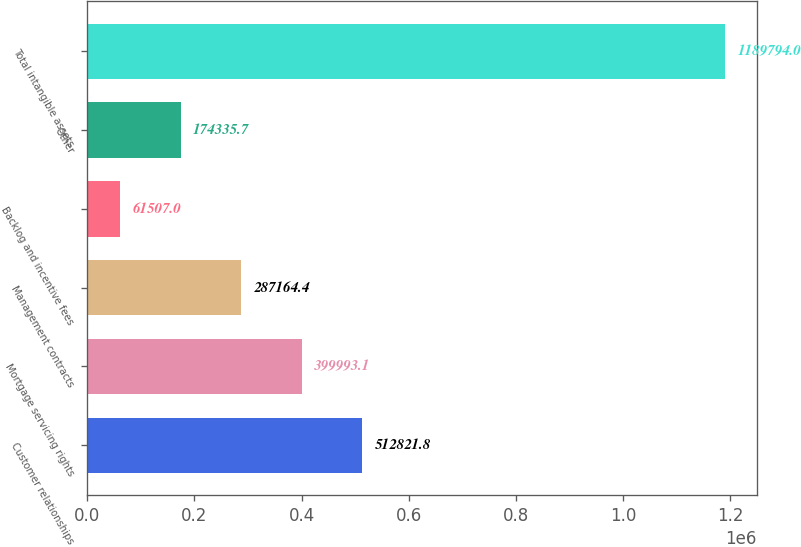Convert chart. <chart><loc_0><loc_0><loc_500><loc_500><bar_chart><fcel>Customer relationships<fcel>Mortgage servicing rights<fcel>Management contracts<fcel>Backlog and incentive fees<fcel>Other<fcel>Total intangible assets<nl><fcel>512822<fcel>399993<fcel>287164<fcel>61507<fcel>174336<fcel>1.18979e+06<nl></chart> 